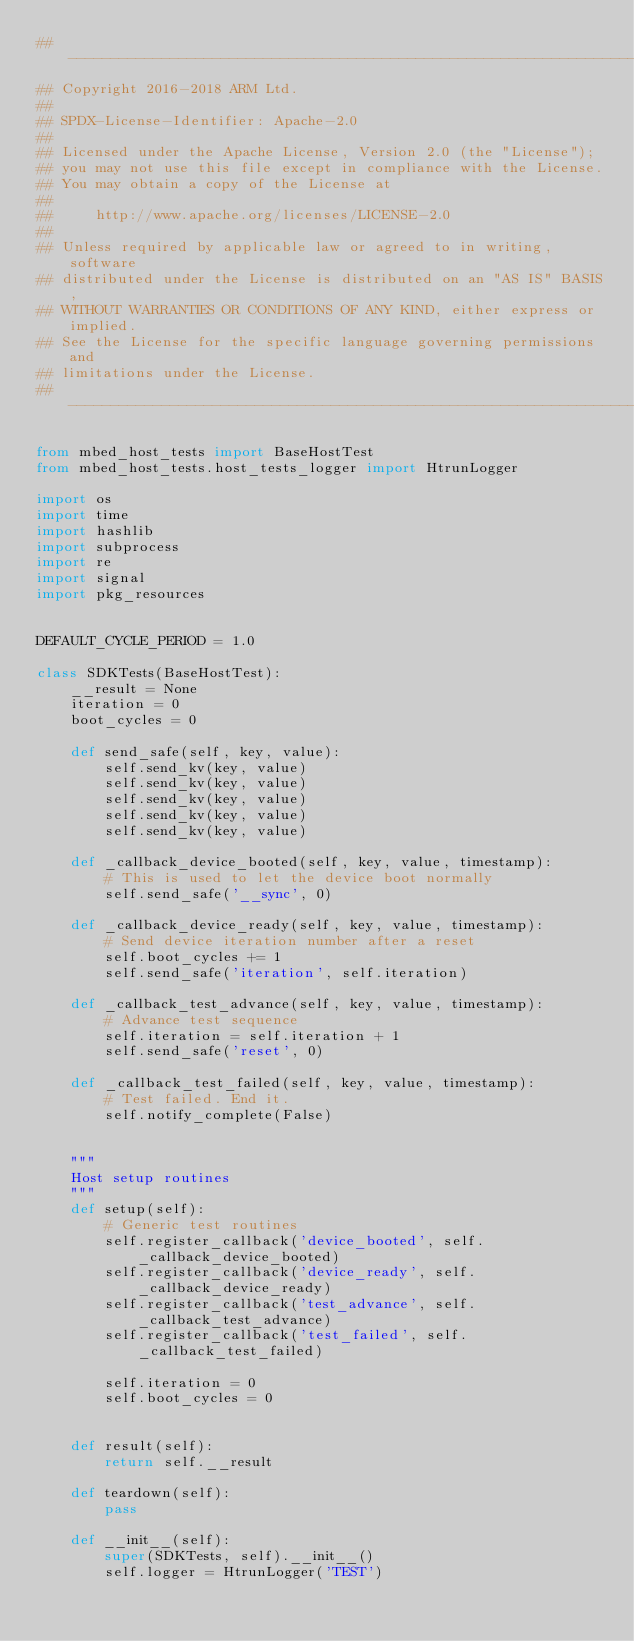Convert code to text. <code><loc_0><loc_0><loc_500><loc_500><_Python_>## ----------------------------------------------------------------------------
## Copyright 2016-2018 ARM Ltd.
##
## SPDX-License-Identifier: Apache-2.0
##
## Licensed under the Apache License, Version 2.0 (the "License");
## you may not use this file except in compliance with the License.
## You may obtain a copy of the License at
##
##     http://www.apache.org/licenses/LICENSE-2.0
##
## Unless required by applicable law or agreed to in writing, software
## distributed under the License is distributed on an "AS IS" BASIS,
## WITHOUT WARRANTIES OR CONDITIONS OF ANY KIND, either express or implied.
## See the License for the specific language governing permissions and
## limitations under the License.
## ----------------------------------------------------------------------------

from mbed_host_tests import BaseHostTest
from mbed_host_tests.host_tests_logger import HtrunLogger

import os
import time
import hashlib
import subprocess
import re
import signal
import pkg_resources


DEFAULT_CYCLE_PERIOD = 1.0

class SDKTests(BaseHostTest):
    __result = None
    iteration = 0
    boot_cycles = 0

    def send_safe(self, key, value):
        self.send_kv(key, value)
        self.send_kv(key, value)
        self.send_kv(key, value)
        self.send_kv(key, value)
        self.send_kv(key, value)

    def _callback_device_booted(self, key, value, timestamp): 
        # This is used to let the device boot normally
        self.send_safe('__sync', 0)

    def _callback_device_ready(self, key, value, timestamp):
        # Send device iteration number after a reset
        self.boot_cycles += 1
        self.send_safe('iteration', self.iteration)

    def _callback_test_advance(self, key, value, timestamp):
        # Advance test sequence
        self.iteration = self.iteration + 1
        self.send_safe('reset', 0)

    def _callback_test_failed(self, key, value, timestamp):
        # Test failed. End it.
        self.notify_complete(False)


    """
    Host setup routines
    """
    def setup(self):
        # Generic test routines
        self.register_callback('device_booted', self._callback_device_booted)
        self.register_callback('device_ready', self._callback_device_ready)
        self.register_callback('test_advance', self._callback_test_advance)
        self.register_callback('test_failed', self._callback_test_failed)

        self.iteration = 0
        self.boot_cycles = 0


    def result(self):
        return self.__result

    def teardown(self):
        pass

    def __init__(self):
        super(SDKTests, self).__init__()
        self.logger = HtrunLogger('TEST')</code> 